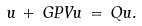Convert formula to latex. <formula><loc_0><loc_0><loc_500><loc_500>u \, + \, G P V u \, = \, Q u .</formula> 